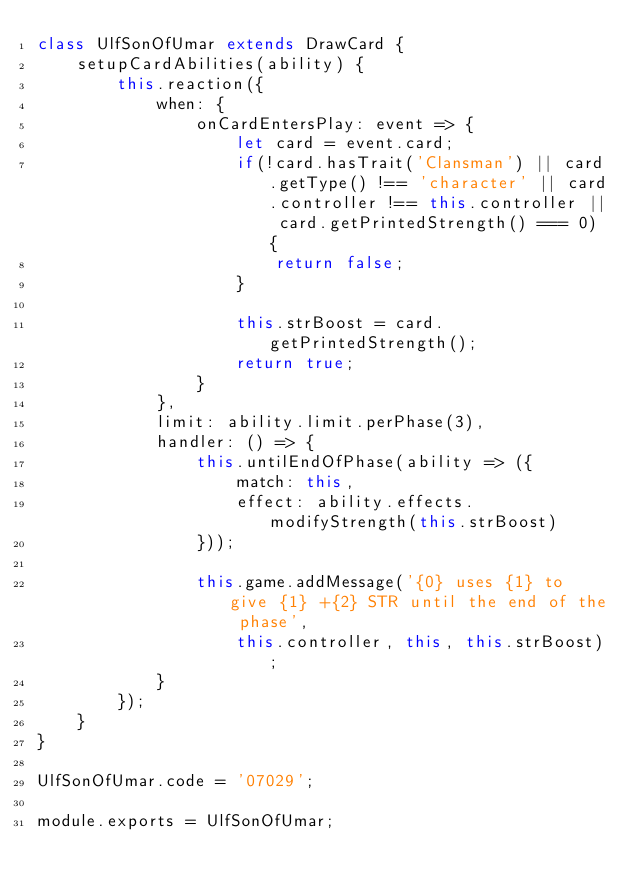Convert code to text. <code><loc_0><loc_0><loc_500><loc_500><_JavaScript_>class UlfSonOfUmar extends DrawCard {
    setupCardAbilities(ability) {
        this.reaction({
            when: {
                onCardEntersPlay: event => {
                    let card = event.card;
                    if(!card.hasTrait('Clansman') || card.getType() !== 'character' || card.controller !== this.controller || card.getPrintedStrength() === 0) {
                        return false;
                    }

                    this.strBoost = card.getPrintedStrength();
                    return true;
                }             
            },
            limit: ability.limit.perPhase(3),
            handler: () => {
                this.untilEndOfPhase(ability => ({
                    match: this,
                    effect: ability.effects.modifyStrength(this.strBoost)
                }));        

                this.game.addMessage('{0} uses {1} to give {1} +{2} STR until the end of the phase', 
                    this.controller, this, this.strBoost);
            }
        });
    }
}

UlfSonOfUmar.code = '07029';

module.exports = UlfSonOfUmar;
</code> 